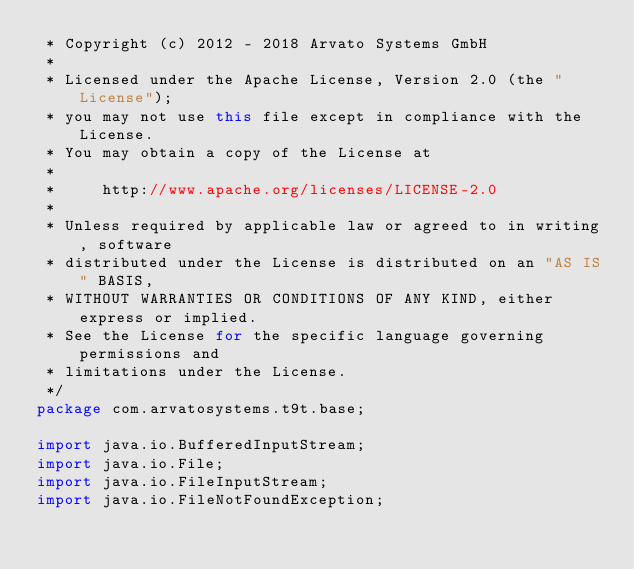Convert code to text. <code><loc_0><loc_0><loc_500><loc_500><_Java_> * Copyright (c) 2012 - 2018 Arvato Systems GmbH
 *
 * Licensed under the Apache License, Version 2.0 (the "License");
 * you may not use this file except in compliance with the License.
 * You may obtain a copy of the License at
 *
 *     http://www.apache.org/licenses/LICENSE-2.0
 *
 * Unless required by applicable law or agreed to in writing, software
 * distributed under the License is distributed on an "AS IS" BASIS,
 * WITHOUT WARRANTIES OR CONDITIONS OF ANY KIND, either express or implied.
 * See the License for the specific language governing permissions and
 * limitations under the License.
 */
package com.arvatosystems.t9t.base;

import java.io.BufferedInputStream;
import java.io.File;
import java.io.FileInputStream;
import java.io.FileNotFoundException;</code> 